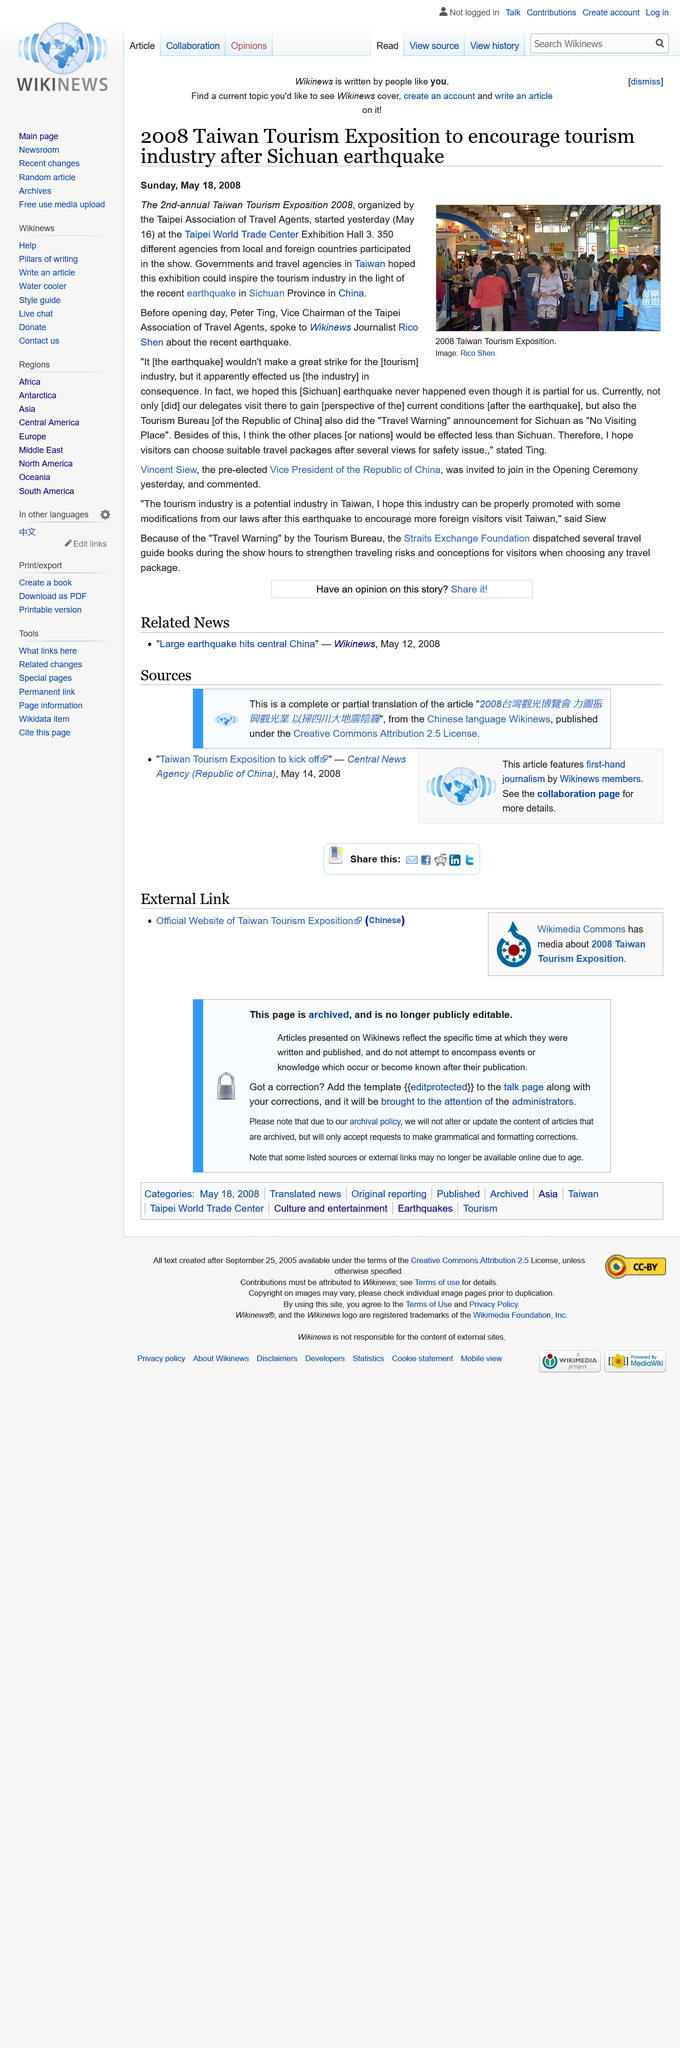Mention a couple of crucial points in this snapshot. The show featured the participation of 350 different agencies from local and foreign countries, reflecting the diverse range of creative talents and resources available in the industry. The image depicts a large gathering of people attending the 2008 Taiwan Tourism Exposition. The 2nd Annual Taiwan Tourism Exposition 2008 was organized by the Taipei Association of Travel Agents. 